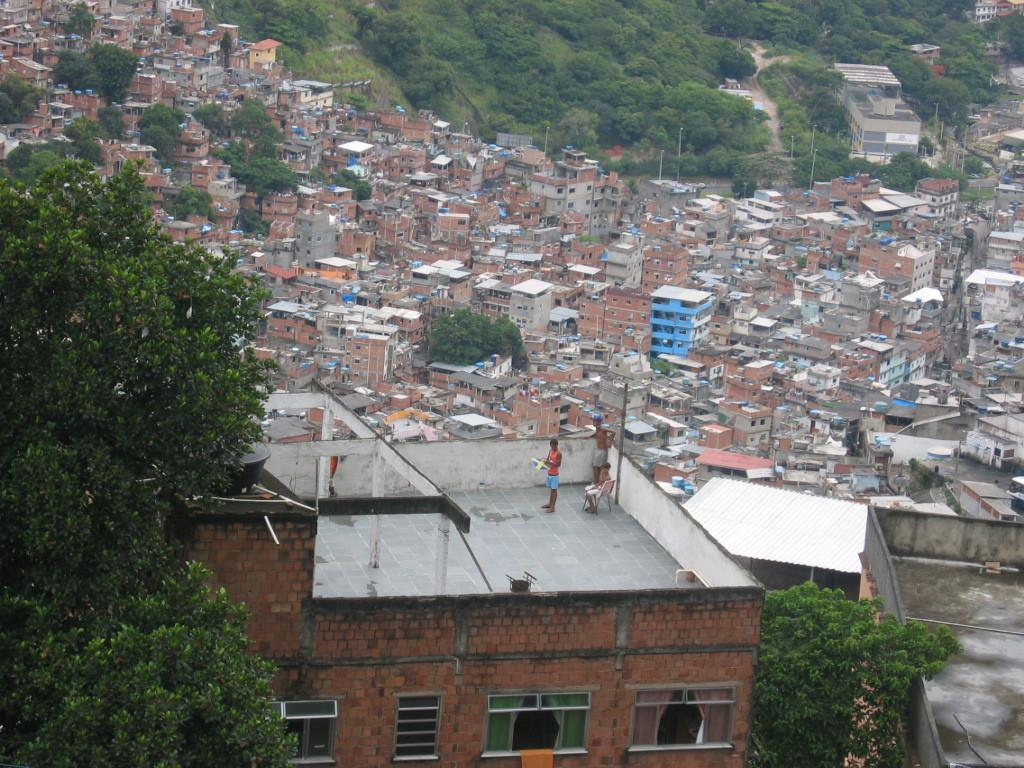What type of structures can be seen in the image? There are houses in the image. Can you describe the people in the image? There are three persons on a building in the image. What can be seen in the background of the image? There are trees in the background of the image. What type of oven can be seen in the image? There is no oven present in the image. What is the reason for the persons saying good-bye in the image? There is no indication in the image that the persons are saying good-bye, nor is there any context provided to suggest a reason for them to do so. 